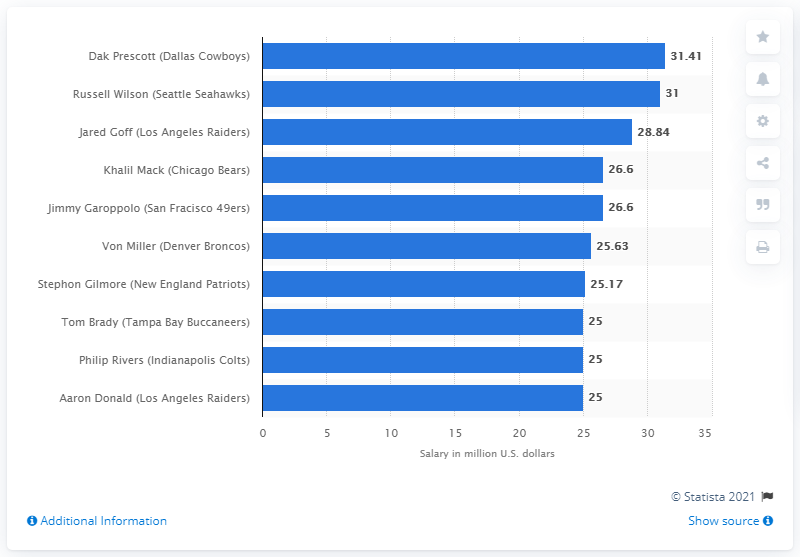Specify some key components in this picture. The Dallas Cowboys signed Dak Prescott to a new contract in March 2020, awarding him a significant sum of 31.41 million dollars. 